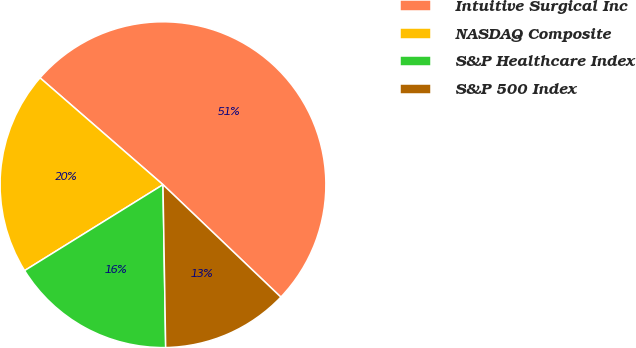Convert chart to OTSL. <chart><loc_0><loc_0><loc_500><loc_500><pie_chart><fcel>Intuitive Surgical Inc<fcel>NASDAQ Composite<fcel>S&P Healthcare Index<fcel>S&P 500 Index<nl><fcel>50.74%<fcel>20.23%<fcel>16.42%<fcel>12.61%<nl></chart> 